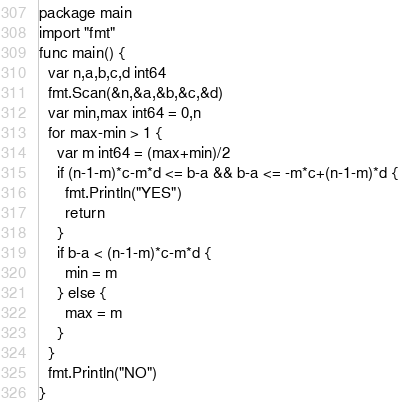<code> <loc_0><loc_0><loc_500><loc_500><_Go_>package main
import "fmt"
func main() {
  var n,a,b,c,d int64
  fmt.Scan(&n,&a,&b,&c,&d)
  var min,max int64 = 0,n
  for max-min > 1 {
    var m int64 = (max+min)/2
    if (n-1-m)*c-m*d <= b-a && b-a <= -m*c+(n-1-m)*d {
      fmt.Println("YES")
      return
    }
    if b-a < (n-1-m)*c-m*d {
      min = m
    } else {
      max = m
    }
  }
  fmt.Println("NO")
}</code> 